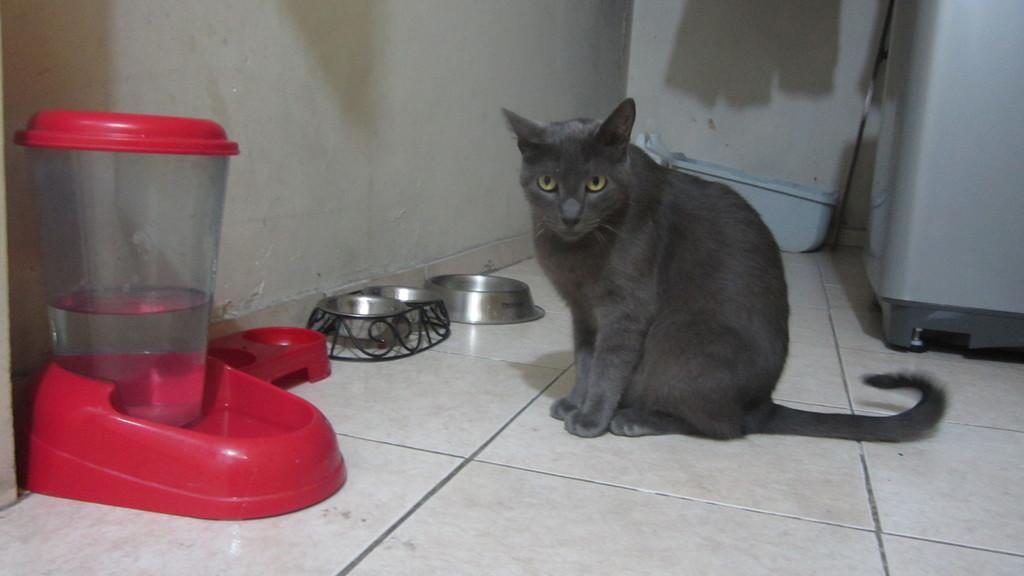How would you summarize this image in a sentence or two? In this image, we can see a cat, some bowls, stands and a jar with water and we can see a container and a washing machine are on the floor. 